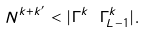<formula> <loc_0><loc_0><loc_500><loc_500>N ^ { k + k ^ { \prime } } < | \Gamma ^ { k } \ \Gamma ^ { k } _ { L - 1 } | .</formula> 